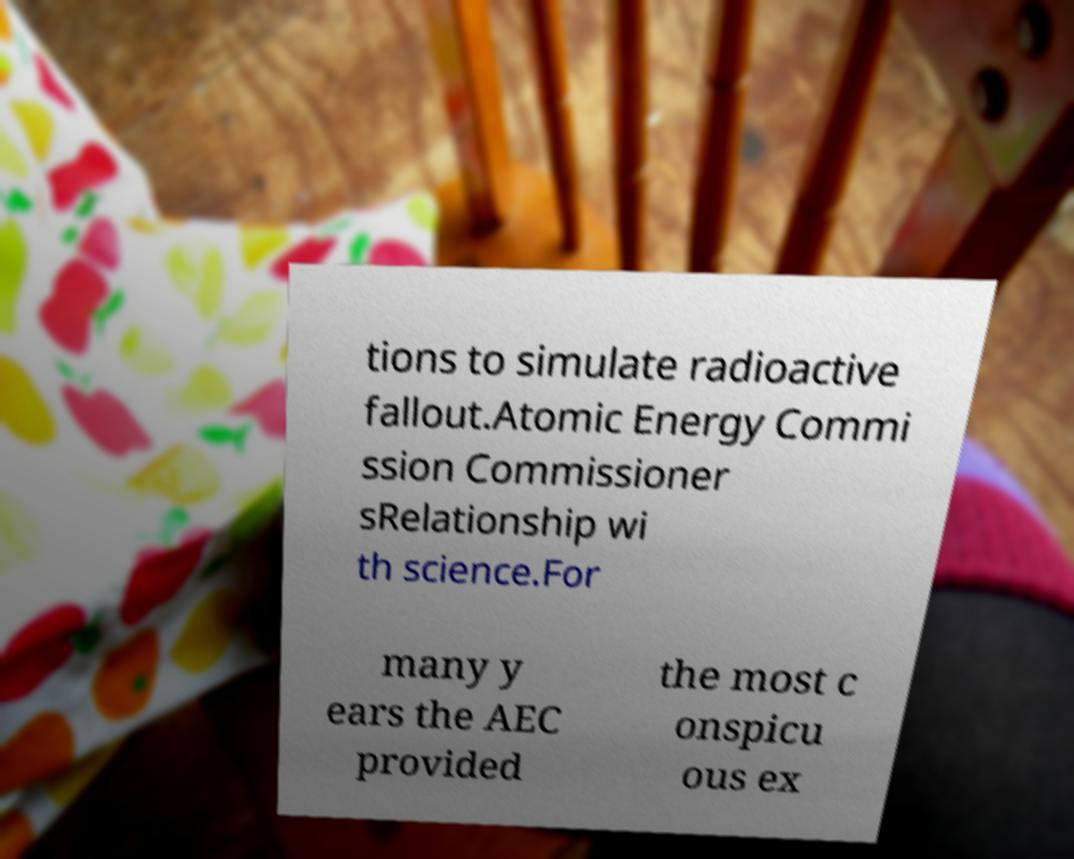I need the written content from this picture converted into text. Can you do that? tions to simulate radioactive fallout.Atomic Energy Commi ssion Commissioner sRelationship wi th science.For many y ears the AEC provided the most c onspicu ous ex 